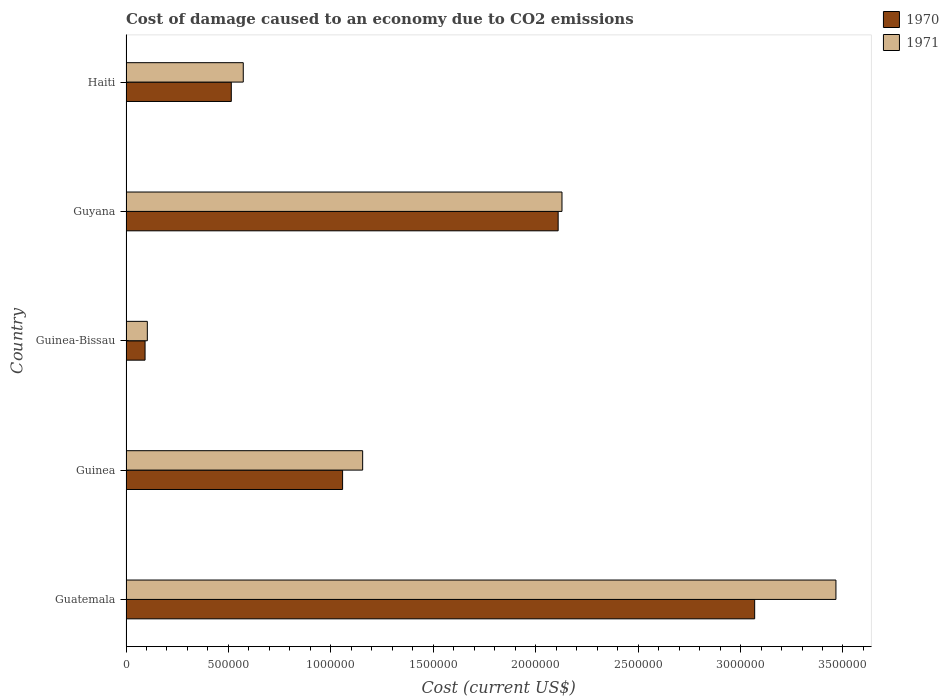How many different coloured bars are there?
Your answer should be very brief. 2. How many groups of bars are there?
Give a very brief answer. 5. Are the number of bars per tick equal to the number of legend labels?
Ensure brevity in your answer.  Yes. Are the number of bars on each tick of the Y-axis equal?
Offer a very short reply. Yes. How many bars are there on the 5th tick from the bottom?
Make the answer very short. 2. What is the label of the 1st group of bars from the top?
Give a very brief answer. Haiti. What is the cost of damage caused due to CO2 emissisons in 1970 in Haiti?
Make the answer very short. 5.14e+05. Across all countries, what is the maximum cost of damage caused due to CO2 emissisons in 1970?
Offer a very short reply. 3.07e+06. Across all countries, what is the minimum cost of damage caused due to CO2 emissisons in 1971?
Your response must be concise. 1.04e+05. In which country was the cost of damage caused due to CO2 emissisons in 1970 maximum?
Offer a very short reply. Guatemala. In which country was the cost of damage caused due to CO2 emissisons in 1970 minimum?
Keep it short and to the point. Guinea-Bissau. What is the total cost of damage caused due to CO2 emissisons in 1971 in the graph?
Offer a terse response. 7.43e+06. What is the difference between the cost of damage caused due to CO2 emissisons in 1970 in Guinea-Bissau and that in Haiti?
Your response must be concise. -4.21e+05. What is the difference between the cost of damage caused due to CO2 emissisons in 1971 in Guyana and the cost of damage caused due to CO2 emissisons in 1970 in Haiti?
Offer a very short reply. 1.61e+06. What is the average cost of damage caused due to CO2 emissisons in 1971 per country?
Provide a short and direct response. 1.49e+06. What is the difference between the cost of damage caused due to CO2 emissisons in 1970 and cost of damage caused due to CO2 emissisons in 1971 in Haiti?
Give a very brief answer. -5.85e+04. In how many countries, is the cost of damage caused due to CO2 emissisons in 1970 greater than 1500000 US$?
Ensure brevity in your answer.  2. What is the ratio of the cost of damage caused due to CO2 emissisons in 1970 in Guinea to that in Guinea-Bissau?
Offer a very short reply. 11.37. Is the difference between the cost of damage caused due to CO2 emissisons in 1970 in Guinea and Haiti greater than the difference between the cost of damage caused due to CO2 emissisons in 1971 in Guinea and Haiti?
Offer a terse response. No. What is the difference between the highest and the second highest cost of damage caused due to CO2 emissisons in 1970?
Give a very brief answer. 9.59e+05. What is the difference between the highest and the lowest cost of damage caused due to CO2 emissisons in 1971?
Give a very brief answer. 3.36e+06. Are the values on the major ticks of X-axis written in scientific E-notation?
Your response must be concise. No. Does the graph contain any zero values?
Provide a short and direct response. No. Does the graph contain grids?
Make the answer very short. No. Where does the legend appear in the graph?
Your answer should be compact. Top right. How many legend labels are there?
Give a very brief answer. 2. What is the title of the graph?
Give a very brief answer. Cost of damage caused to an economy due to CO2 emissions. Does "1985" appear as one of the legend labels in the graph?
Make the answer very short. No. What is the label or title of the X-axis?
Your response must be concise. Cost (current US$). What is the label or title of the Y-axis?
Ensure brevity in your answer.  Country. What is the Cost (current US$) in 1970 in Guatemala?
Provide a short and direct response. 3.07e+06. What is the Cost (current US$) of 1971 in Guatemala?
Provide a short and direct response. 3.47e+06. What is the Cost (current US$) in 1970 in Guinea?
Make the answer very short. 1.06e+06. What is the Cost (current US$) in 1971 in Guinea?
Ensure brevity in your answer.  1.16e+06. What is the Cost (current US$) of 1970 in Guinea-Bissau?
Ensure brevity in your answer.  9.30e+04. What is the Cost (current US$) in 1971 in Guinea-Bissau?
Make the answer very short. 1.04e+05. What is the Cost (current US$) in 1970 in Guyana?
Your answer should be very brief. 2.11e+06. What is the Cost (current US$) of 1971 in Guyana?
Offer a very short reply. 2.13e+06. What is the Cost (current US$) in 1970 in Haiti?
Your answer should be very brief. 5.14e+05. What is the Cost (current US$) in 1971 in Haiti?
Keep it short and to the point. 5.72e+05. Across all countries, what is the maximum Cost (current US$) in 1970?
Make the answer very short. 3.07e+06. Across all countries, what is the maximum Cost (current US$) in 1971?
Your answer should be very brief. 3.47e+06. Across all countries, what is the minimum Cost (current US$) in 1970?
Your answer should be very brief. 9.30e+04. Across all countries, what is the minimum Cost (current US$) of 1971?
Offer a terse response. 1.04e+05. What is the total Cost (current US$) of 1970 in the graph?
Your answer should be very brief. 6.84e+06. What is the total Cost (current US$) of 1971 in the graph?
Your answer should be compact. 7.43e+06. What is the difference between the Cost (current US$) of 1970 in Guatemala and that in Guinea?
Keep it short and to the point. 2.01e+06. What is the difference between the Cost (current US$) in 1971 in Guatemala and that in Guinea?
Your answer should be very brief. 2.31e+06. What is the difference between the Cost (current US$) in 1970 in Guatemala and that in Guinea-Bissau?
Your answer should be very brief. 2.98e+06. What is the difference between the Cost (current US$) in 1971 in Guatemala and that in Guinea-Bissau?
Your answer should be compact. 3.36e+06. What is the difference between the Cost (current US$) in 1970 in Guatemala and that in Guyana?
Make the answer very short. 9.59e+05. What is the difference between the Cost (current US$) in 1971 in Guatemala and that in Guyana?
Ensure brevity in your answer.  1.34e+06. What is the difference between the Cost (current US$) in 1970 in Guatemala and that in Haiti?
Give a very brief answer. 2.56e+06. What is the difference between the Cost (current US$) in 1971 in Guatemala and that in Haiti?
Provide a short and direct response. 2.89e+06. What is the difference between the Cost (current US$) of 1970 in Guinea and that in Guinea-Bissau?
Provide a short and direct response. 9.64e+05. What is the difference between the Cost (current US$) in 1971 in Guinea and that in Guinea-Bissau?
Provide a succinct answer. 1.05e+06. What is the difference between the Cost (current US$) in 1970 in Guinea and that in Guyana?
Ensure brevity in your answer.  -1.05e+06. What is the difference between the Cost (current US$) of 1971 in Guinea and that in Guyana?
Your answer should be compact. -9.73e+05. What is the difference between the Cost (current US$) in 1970 in Guinea and that in Haiti?
Your answer should be very brief. 5.43e+05. What is the difference between the Cost (current US$) in 1971 in Guinea and that in Haiti?
Your response must be concise. 5.83e+05. What is the difference between the Cost (current US$) in 1970 in Guinea-Bissau and that in Guyana?
Provide a short and direct response. -2.02e+06. What is the difference between the Cost (current US$) in 1971 in Guinea-Bissau and that in Guyana?
Your answer should be very brief. -2.02e+06. What is the difference between the Cost (current US$) in 1970 in Guinea-Bissau and that in Haiti?
Provide a short and direct response. -4.21e+05. What is the difference between the Cost (current US$) of 1971 in Guinea-Bissau and that in Haiti?
Your answer should be very brief. -4.68e+05. What is the difference between the Cost (current US$) in 1970 in Guyana and that in Haiti?
Offer a terse response. 1.60e+06. What is the difference between the Cost (current US$) in 1971 in Guyana and that in Haiti?
Ensure brevity in your answer.  1.56e+06. What is the difference between the Cost (current US$) of 1970 in Guatemala and the Cost (current US$) of 1971 in Guinea?
Offer a very short reply. 1.91e+06. What is the difference between the Cost (current US$) in 1970 in Guatemala and the Cost (current US$) in 1971 in Guinea-Bissau?
Provide a succinct answer. 2.96e+06. What is the difference between the Cost (current US$) of 1970 in Guatemala and the Cost (current US$) of 1971 in Guyana?
Keep it short and to the point. 9.41e+05. What is the difference between the Cost (current US$) in 1970 in Guatemala and the Cost (current US$) in 1971 in Haiti?
Provide a succinct answer. 2.50e+06. What is the difference between the Cost (current US$) in 1970 in Guinea and the Cost (current US$) in 1971 in Guinea-Bissau?
Your answer should be very brief. 9.53e+05. What is the difference between the Cost (current US$) in 1970 in Guinea and the Cost (current US$) in 1971 in Guyana?
Give a very brief answer. -1.07e+06. What is the difference between the Cost (current US$) of 1970 in Guinea and the Cost (current US$) of 1971 in Haiti?
Your answer should be very brief. 4.85e+05. What is the difference between the Cost (current US$) in 1970 in Guinea-Bissau and the Cost (current US$) in 1971 in Guyana?
Offer a terse response. -2.04e+06. What is the difference between the Cost (current US$) of 1970 in Guinea-Bissau and the Cost (current US$) of 1971 in Haiti?
Keep it short and to the point. -4.79e+05. What is the difference between the Cost (current US$) of 1970 in Guyana and the Cost (current US$) of 1971 in Haiti?
Your answer should be very brief. 1.54e+06. What is the average Cost (current US$) in 1970 per country?
Keep it short and to the point. 1.37e+06. What is the average Cost (current US$) of 1971 per country?
Offer a very short reply. 1.49e+06. What is the difference between the Cost (current US$) in 1970 and Cost (current US$) in 1971 in Guatemala?
Give a very brief answer. -3.97e+05. What is the difference between the Cost (current US$) of 1970 and Cost (current US$) of 1971 in Guinea?
Provide a short and direct response. -9.80e+04. What is the difference between the Cost (current US$) of 1970 and Cost (current US$) of 1971 in Guinea-Bissau?
Provide a short and direct response. -1.11e+04. What is the difference between the Cost (current US$) in 1970 and Cost (current US$) in 1971 in Guyana?
Give a very brief answer. -1.87e+04. What is the difference between the Cost (current US$) of 1970 and Cost (current US$) of 1971 in Haiti?
Offer a terse response. -5.85e+04. What is the ratio of the Cost (current US$) of 1970 in Guatemala to that in Guinea?
Offer a terse response. 2.9. What is the ratio of the Cost (current US$) in 1971 in Guatemala to that in Guinea?
Your answer should be very brief. 3. What is the ratio of the Cost (current US$) in 1970 in Guatemala to that in Guinea-Bissau?
Your answer should be very brief. 33. What is the ratio of the Cost (current US$) of 1971 in Guatemala to that in Guinea-Bissau?
Give a very brief answer. 33.3. What is the ratio of the Cost (current US$) of 1970 in Guatemala to that in Guyana?
Your answer should be very brief. 1.45. What is the ratio of the Cost (current US$) of 1971 in Guatemala to that in Guyana?
Offer a very short reply. 1.63. What is the ratio of the Cost (current US$) of 1970 in Guatemala to that in Haiti?
Offer a very short reply. 5.97. What is the ratio of the Cost (current US$) of 1971 in Guatemala to that in Haiti?
Make the answer very short. 6.05. What is the ratio of the Cost (current US$) in 1970 in Guinea to that in Guinea-Bissau?
Offer a very short reply. 11.37. What is the ratio of the Cost (current US$) of 1971 in Guinea to that in Guinea-Bissau?
Make the answer very short. 11.1. What is the ratio of the Cost (current US$) of 1970 in Guinea to that in Guyana?
Keep it short and to the point. 0.5. What is the ratio of the Cost (current US$) in 1971 in Guinea to that in Guyana?
Your answer should be compact. 0.54. What is the ratio of the Cost (current US$) in 1970 in Guinea to that in Haiti?
Make the answer very short. 2.06. What is the ratio of the Cost (current US$) in 1971 in Guinea to that in Haiti?
Keep it short and to the point. 2.02. What is the ratio of the Cost (current US$) in 1970 in Guinea-Bissau to that in Guyana?
Keep it short and to the point. 0.04. What is the ratio of the Cost (current US$) of 1971 in Guinea-Bissau to that in Guyana?
Give a very brief answer. 0.05. What is the ratio of the Cost (current US$) of 1970 in Guinea-Bissau to that in Haiti?
Your answer should be very brief. 0.18. What is the ratio of the Cost (current US$) in 1971 in Guinea-Bissau to that in Haiti?
Provide a short and direct response. 0.18. What is the ratio of the Cost (current US$) in 1970 in Guyana to that in Haiti?
Provide a succinct answer. 4.1. What is the ratio of the Cost (current US$) of 1971 in Guyana to that in Haiti?
Your answer should be compact. 3.72. What is the difference between the highest and the second highest Cost (current US$) of 1970?
Offer a very short reply. 9.59e+05. What is the difference between the highest and the second highest Cost (current US$) of 1971?
Your response must be concise. 1.34e+06. What is the difference between the highest and the lowest Cost (current US$) of 1970?
Your answer should be compact. 2.98e+06. What is the difference between the highest and the lowest Cost (current US$) of 1971?
Provide a succinct answer. 3.36e+06. 